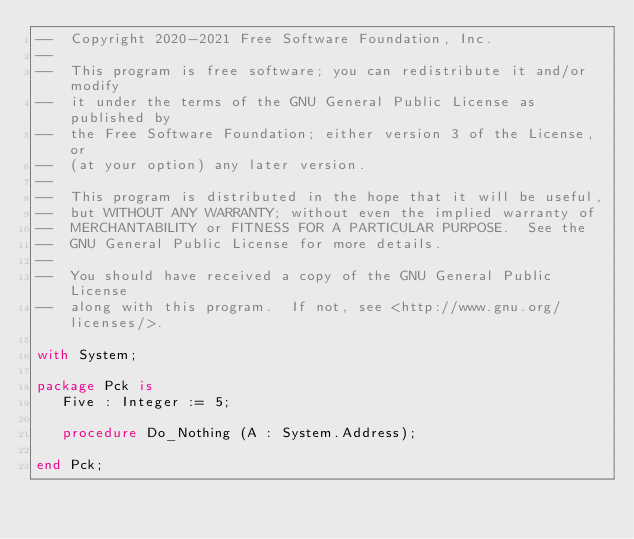Convert code to text. <code><loc_0><loc_0><loc_500><loc_500><_Ada_>--  Copyright 2020-2021 Free Software Foundation, Inc.
--
--  This program is free software; you can redistribute it and/or modify
--  it under the terms of the GNU General Public License as published by
--  the Free Software Foundation; either version 3 of the License, or
--  (at your option) any later version.
--
--  This program is distributed in the hope that it will be useful,
--  but WITHOUT ANY WARRANTY; without even the implied warranty of
--  MERCHANTABILITY or FITNESS FOR A PARTICULAR PURPOSE.  See the
--  GNU General Public License for more details.
--
--  You should have received a copy of the GNU General Public License
--  along with this program.  If not, see <http://www.gnu.org/licenses/>.

with System;

package Pck is
   Five : Integer := 5;

   procedure Do_Nothing (A : System.Address);

end Pck;
</code> 